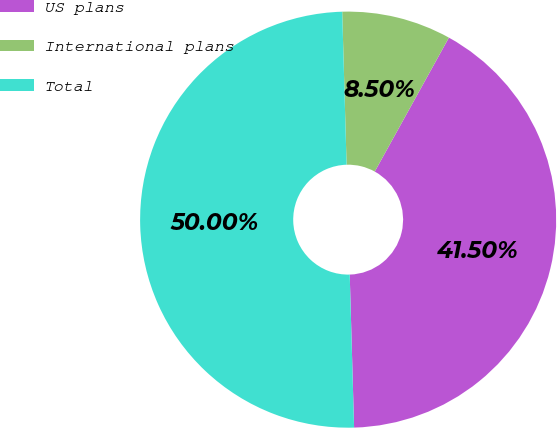Convert chart. <chart><loc_0><loc_0><loc_500><loc_500><pie_chart><fcel>US plans<fcel>International plans<fcel>Total<nl><fcel>41.5%<fcel>8.5%<fcel>50.0%<nl></chart> 